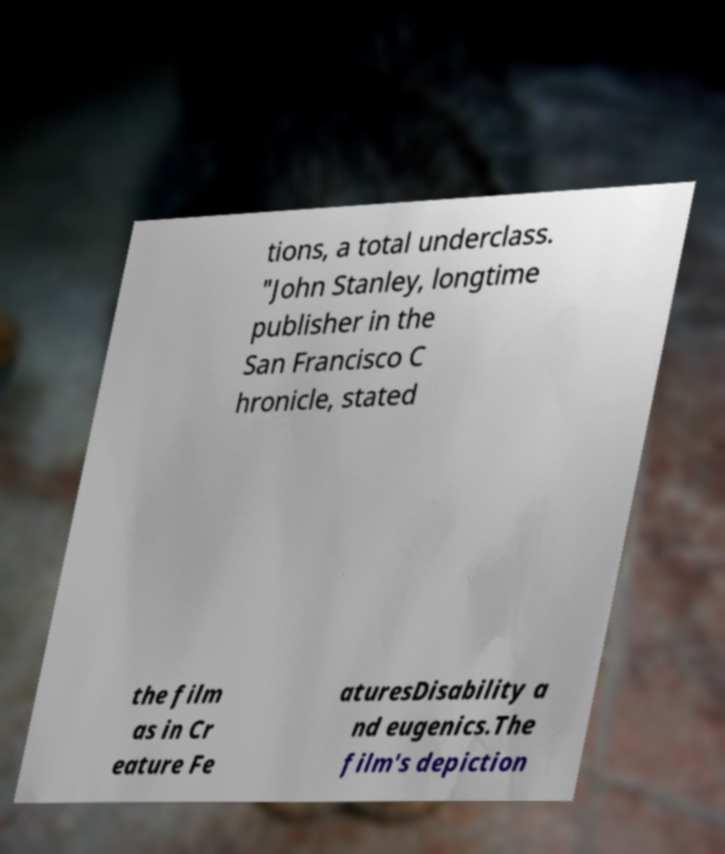Can you accurately transcribe the text from the provided image for me? tions, a total underclass. "John Stanley, longtime publisher in the San Francisco C hronicle, stated the film as in Cr eature Fe aturesDisability a nd eugenics.The film's depiction 